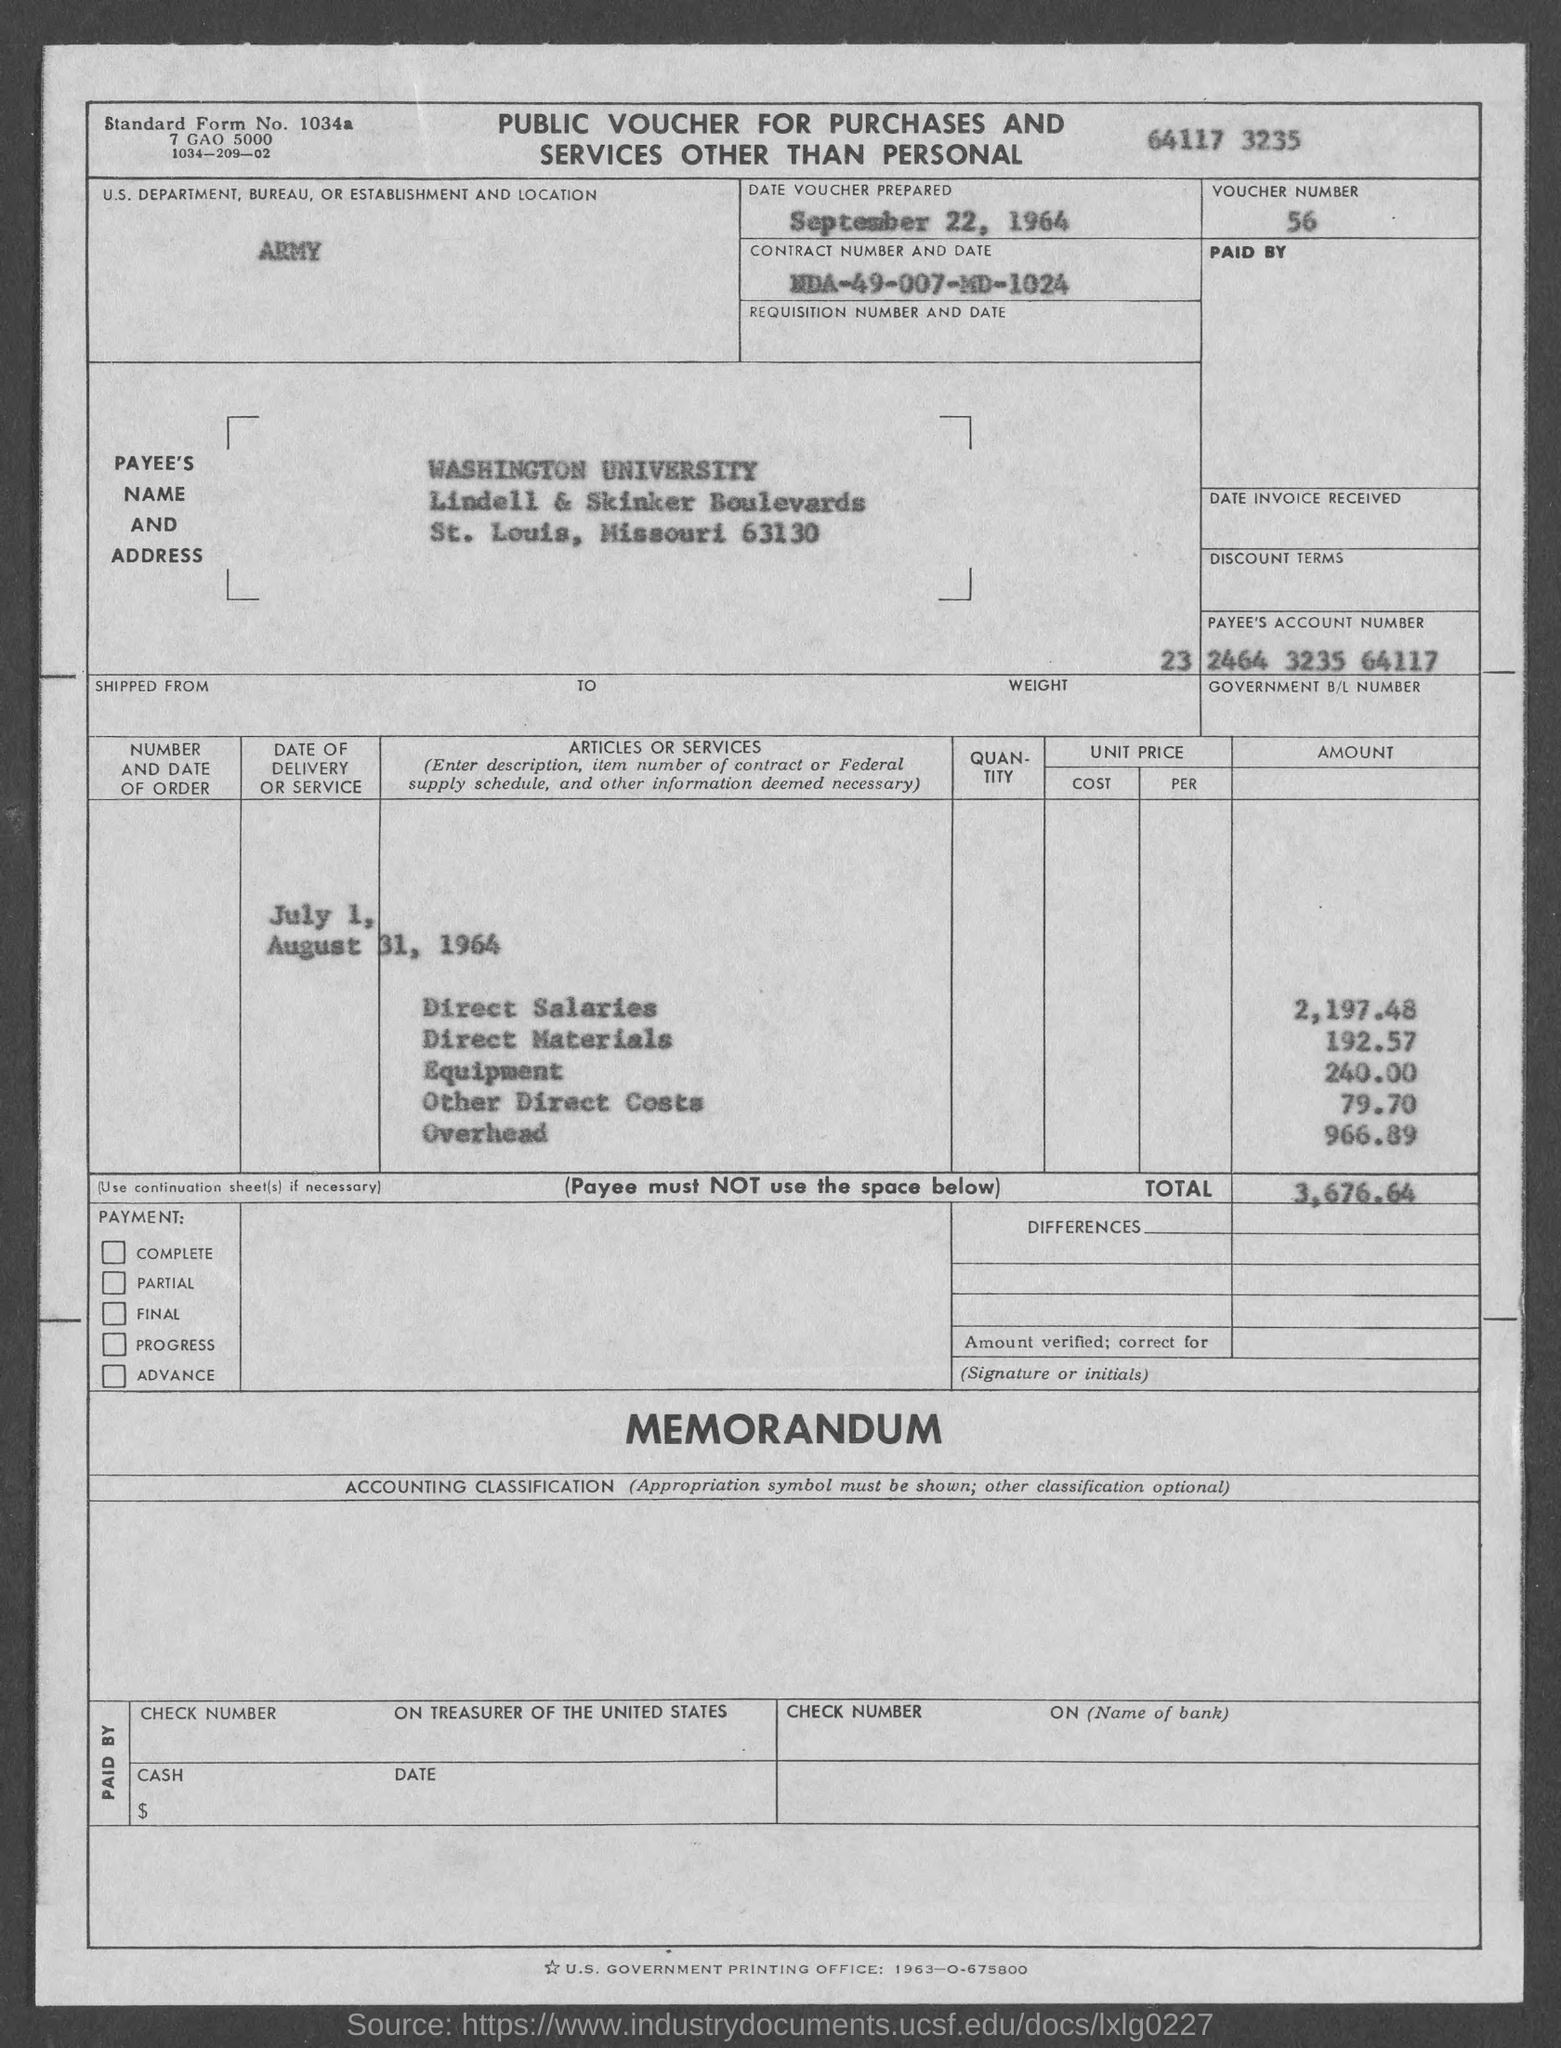What’s the significance of this voucher’s date? This voucher is dated September 22, 1964. It's a historical document possibly related to university funding or research expenses during that period. 